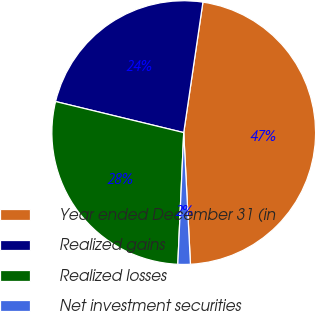Convert chart. <chart><loc_0><loc_0><loc_500><loc_500><pie_chart><fcel>Year ended December 31 (in<fcel>Realized gains<fcel>Realized losses<fcel>Net investment securities<nl><fcel>46.86%<fcel>23.54%<fcel>28.07%<fcel>1.53%<nl></chart> 